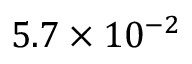<formula> <loc_0><loc_0><loc_500><loc_500>5 . 7 \times 1 0 ^ { - 2 }</formula> 